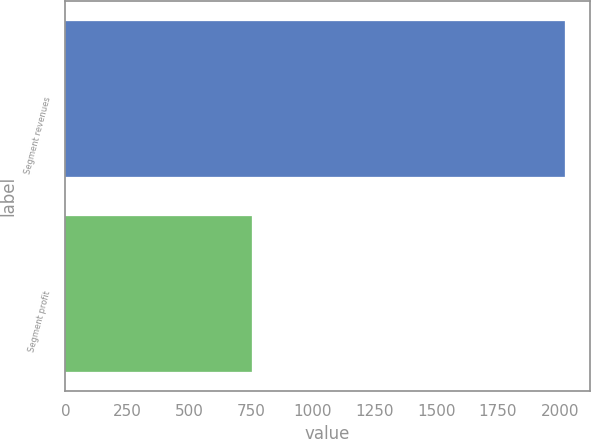Convert chart to OTSL. <chart><loc_0><loc_0><loc_500><loc_500><bar_chart><fcel>Segment revenues<fcel>Segment profit<nl><fcel>2021<fcel>756<nl></chart> 